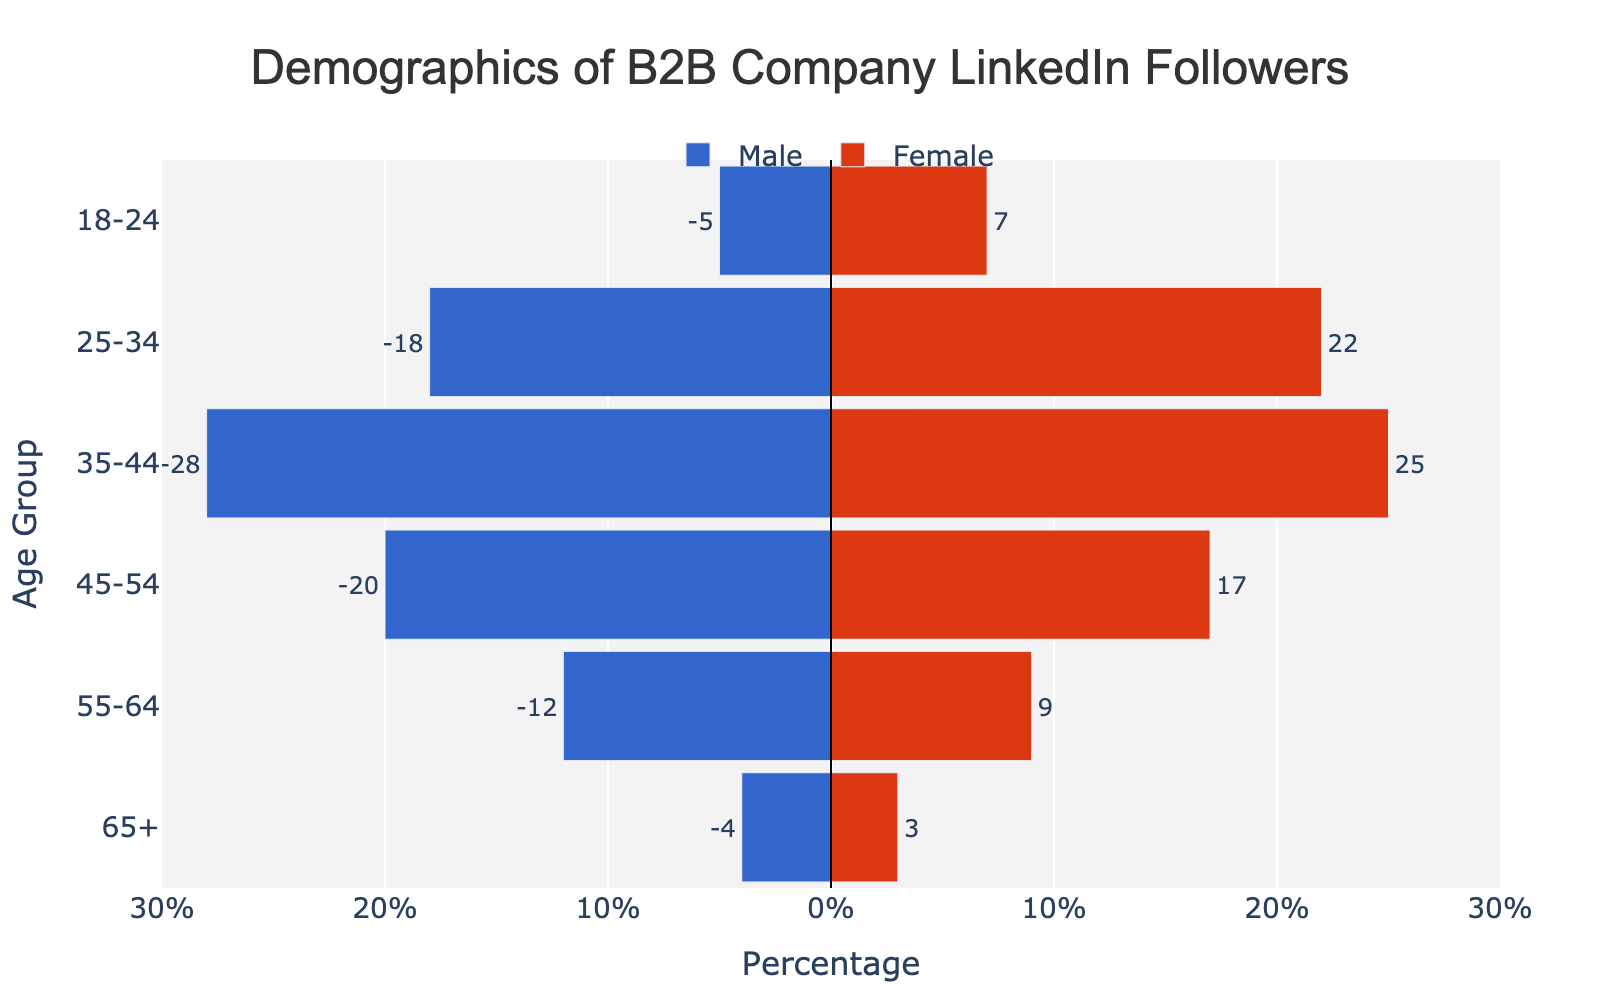what is the title of the figure? The title is typically at the top of the figure and is designed to summarize the key contents or purpose of the chart. In this case, the title reads "Demographics of B2B Company LinkedIn Followers."
Answer: Demographics of B2B Company LinkedIn Followers What values are on the x-axis? The x-axis represents percentages. It ranges from -30 to 30, with tick values marked at intervals of 10 (i.e., -30, -20, -10, 0, 10, 20, 30).
Answer: Percentages Which age group has the highest number of male followers? To find this, look for the longest bar on the negative (left) side of the x-axis, representing male followers. The age group 35-44 has the longest bar on the left side.
Answer: 35-44 What is the combined number of male and female followers in the 45-54 age group? The number of male followers is 20, and the number of female followers is 17. Adding these together gives 20 + 17 = 37.
Answer: 37 In the 25-34 age group, how many more female followers are there than male followers? First, find the values for the 25-34 age group. There are 22 female followers and 18 male followers. The difference is 22 - 18 = 4.
Answer: 4 Which gender has more followers in the age group 55-64? Compare the number of male and female followers. For the 55-64 age group, there are 12 male followers and 9 female followers. 12 is greater than 9, so there are more male followers.
Answer: Male What is the total number of followers in the 18-24 age group? Add the number of male and female followers in the 18-24 age group. With 5 male followers and 7 female followers, the total is 5 + 7 = 12.
Answer: 12 How many age groups have more female followers than male followers? Compare the number of female followers to the number of male followers for each age group:
- 18-24: 7 females, 5 males (Yes)
- 25-34: 22 females, 18 males (Yes)
- 35-44: 25 females, 28 males (No)
- 45-54: 17 females, 20 males (No)
- 55-64: 9 females, 12 males (No)
- 65+: 3 females, 4 males (No)
Thus, 2 age groups (18-24 and 25-34) have more female followers than male followers.
Answer: 2 Is there any age group where the number of male and female followers is the same? None of the given data points have an equal number of male and female followers. Each age group has a different number for males and females.
Answer: No 